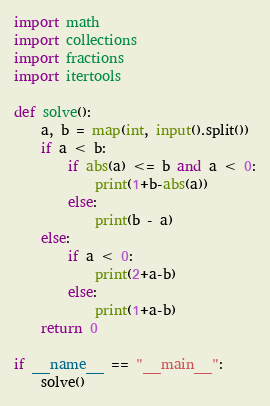Convert code to text. <code><loc_0><loc_0><loc_500><loc_500><_Python_>import math
import collections
import fractions
import itertools

def solve():
    a, b = map(int, input().split())
    if a < b:
        if abs(a) <= b and a < 0:
            print(1+b-abs(a))
        else:
            print(b - a)
    else:
        if a < 0:
            print(2+a-b)
        else:
            print(1+a-b)
    return 0

if __name__ == "__main__":
    solve()</code> 